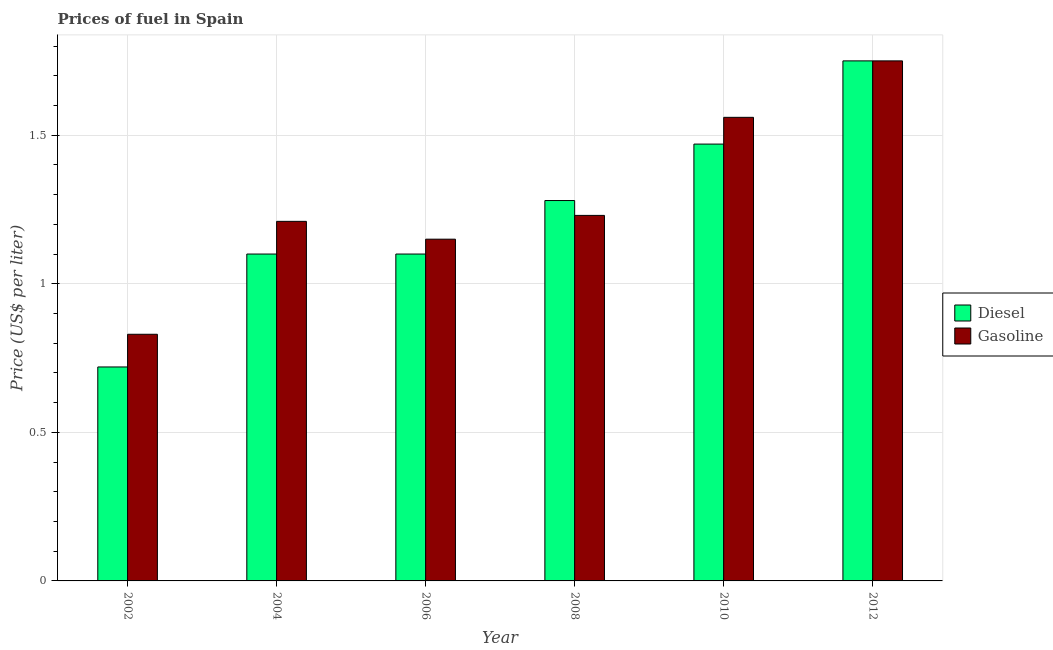Are the number of bars on each tick of the X-axis equal?
Your response must be concise. Yes. How many bars are there on the 2nd tick from the right?
Offer a terse response. 2. In how many cases, is the number of bars for a given year not equal to the number of legend labels?
Your answer should be compact. 0. What is the gasoline price in 2010?
Keep it short and to the point. 1.56. Across all years, what is the maximum gasoline price?
Your answer should be very brief. 1.75. Across all years, what is the minimum diesel price?
Ensure brevity in your answer.  0.72. In which year was the diesel price maximum?
Your answer should be compact. 2012. What is the total diesel price in the graph?
Provide a short and direct response. 7.42. What is the average gasoline price per year?
Provide a short and direct response. 1.29. In how many years, is the diesel price greater than 1.4 US$ per litre?
Provide a succinct answer. 2. What is the ratio of the gasoline price in 2008 to that in 2010?
Provide a short and direct response. 0.79. Is the difference between the gasoline price in 2004 and 2010 greater than the difference between the diesel price in 2004 and 2010?
Your answer should be very brief. No. What is the difference between the highest and the second highest gasoline price?
Offer a very short reply. 0.19. What is the difference between the highest and the lowest diesel price?
Offer a very short reply. 1.03. What does the 1st bar from the left in 2010 represents?
Your answer should be compact. Diesel. What does the 1st bar from the right in 2004 represents?
Give a very brief answer. Gasoline. How many years are there in the graph?
Your answer should be compact. 6. Does the graph contain any zero values?
Keep it short and to the point. No. How are the legend labels stacked?
Ensure brevity in your answer.  Vertical. What is the title of the graph?
Give a very brief answer. Prices of fuel in Spain. Does "Investment in Telecom" appear as one of the legend labels in the graph?
Your answer should be very brief. No. What is the label or title of the X-axis?
Provide a succinct answer. Year. What is the label or title of the Y-axis?
Provide a succinct answer. Price (US$ per liter). What is the Price (US$ per liter) in Diesel in 2002?
Provide a short and direct response. 0.72. What is the Price (US$ per liter) in Gasoline in 2002?
Your answer should be very brief. 0.83. What is the Price (US$ per liter) of Diesel in 2004?
Give a very brief answer. 1.1. What is the Price (US$ per liter) of Gasoline in 2004?
Ensure brevity in your answer.  1.21. What is the Price (US$ per liter) of Gasoline in 2006?
Provide a short and direct response. 1.15. What is the Price (US$ per liter) in Diesel in 2008?
Your response must be concise. 1.28. What is the Price (US$ per liter) in Gasoline in 2008?
Offer a very short reply. 1.23. What is the Price (US$ per liter) of Diesel in 2010?
Offer a terse response. 1.47. What is the Price (US$ per liter) in Gasoline in 2010?
Offer a very short reply. 1.56. Across all years, what is the maximum Price (US$ per liter) of Diesel?
Ensure brevity in your answer.  1.75. Across all years, what is the minimum Price (US$ per liter) in Diesel?
Your response must be concise. 0.72. Across all years, what is the minimum Price (US$ per liter) of Gasoline?
Provide a short and direct response. 0.83. What is the total Price (US$ per liter) of Diesel in the graph?
Your answer should be very brief. 7.42. What is the total Price (US$ per liter) in Gasoline in the graph?
Ensure brevity in your answer.  7.73. What is the difference between the Price (US$ per liter) of Diesel in 2002 and that in 2004?
Offer a terse response. -0.38. What is the difference between the Price (US$ per liter) of Gasoline in 2002 and that in 2004?
Offer a terse response. -0.38. What is the difference between the Price (US$ per liter) in Diesel in 2002 and that in 2006?
Provide a succinct answer. -0.38. What is the difference between the Price (US$ per liter) in Gasoline in 2002 and that in 2006?
Offer a very short reply. -0.32. What is the difference between the Price (US$ per liter) of Diesel in 2002 and that in 2008?
Your response must be concise. -0.56. What is the difference between the Price (US$ per liter) in Gasoline in 2002 and that in 2008?
Your answer should be compact. -0.4. What is the difference between the Price (US$ per liter) in Diesel in 2002 and that in 2010?
Provide a short and direct response. -0.75. What is the difference between the Price (US$ per liter) in Gasoline in 2002 and that in 2010?
Your answer should be compact. -0.73. What is the difference between the Price (US$ per liter) in Diesel in 2002 and that in 2012?
Your response must be concise. -1.03. What is the difference between the Price (US$ per liter) in Gasoline in 2002 and that in 2012?
Give a very brief answer. -0.92. What is the difference between the Price (US$ per liter) in Diesel in 2004 and that in 2006?
Ensure brevity in your answer.  0. What is the difference between the Price (US$ per liter) of Gasoline in 2004 and that in 2006?
Ensure brevity in your answer.  0.06. What is the difference between the Price (US$ per liter) in Diesel in 2004 and that in 2008?
Ensure brevity in your answer.  -0.18. What is the difference between the Price (US$ per liter) in Gasoline in 2004 and that in 2008?
Keep it short and to the point. -0.02. What is the difference between the Price (US$ per liter) of Diesel in 2004 and that in 2010?
Keep it short and to the point. -0.37. What is the difference between the Price (US$ per liter) in Gasoline in 2004 and that in 2010?
Your answer should be very brief. -0.35. What is the difference between the Price (US$ per liter) of Diesel in 2004 and that in 2012?
Make the answer very short. -0.65. What is the difference between the Price (US$ per liter) in Gasoline in 2004 and that in 2012?
Your response must be concise. -0.54. What is the difference between the Price (US$ per liter) of Diesel in 2006 and that in 2008?
Offer a very short reply. -0.18. What is the difference between the Price (US$ per liter) in Gasoline in 2006 and that in 2008?
Offer a terse response. -0.08. What is the difference between the Price (US$ per liter) of Diesel in 2006 and that in 2010?
Give a very brief answer. -0.37. What is the difference between the Price (US$ per liter) in Gasoline in 2006 and that in 2010?
Make the answer very short. -0.41. What is the difference between the Price (US$ per liter) in Diesel in 2006 and that in 2012?
Your answer should be very brief. -0.65. What is the difference between the Price (US$ per liter) of Gasoline in 2006 and that in 2012?
Keep it short and to the point. -0.6. What is the difference between the Price (US$ per liter) in Diesel in 2008 and that in 2010?
Provide a short and direct response. -0.19. What is the difference between the Price (US$ per liter) of Gasoline in 2008 and that in 2010?
Provide a short and direct response. -0.33. What is the difference between the Price (US$ per liter) in Diesel in 2008 and that in 2012?
Your response must be concise. -0.47. What is the difference between the Price (US$ per liter) of Gasoline in 2008 and that in 2012?
Give a very brief answer. -0.52. What is the difference between the Price (US$ per liter) of Diesel in 2010 and that in 2012?
Offer a terse response. -0.28. What is the difference between the Price (US$ per liter) of Gasoline in 2010 and that in 2012?
Make the answer very short. -0.19. What is the difference between the Price (US$ per liter) of Diesel in 2002 and the Price (US$ per liter) of Gasoline in 2004?
Your answer should be compact. -0.49. What is the difference between the Price (US$ per liter) in Diesel in 2002 and the Price (US$ per liter) in Gasoline in 2006?
Your answer should be compact. -0.43. What is the difference between the Price (US$ per liter) in Diesel in 2002 and the Price (US$ per liter) in Gasoline in 2008?
Ensure brevity in your answer.  -0.51. What is the difference between the Price (US$ per liter) in Diesel in 2002 and the Price (US$ per liter) in Gasoline in 2010?
Your answer should be very brief. -0.84. What is the difference between the Price (US$ per liter) of Diesel in 2002 and the Price (US$ per liter) of Gasoline in 2012?
Offer a very short reply. -1.03. What is the difference between the Price (US$ per liter) of Diesel in 2004 and the Price (US$ per liter) of Gasoline in 2008?
Your answer should be compact. -0.13. What is the difference between the Price (US$ per liter) of Diesel in 2004 and the Price (US$ per liter) of Gasoline in 2010?
Provide a short and direct response. -0.46. What is the difference between the Price (US$ per liter) in Diesel in 2004 and the Price (US$ per liter) in Gasoline in 2012?
Offer a terse response. -0.65. What is the difference between the Price (US$ per liter) in Diesel in 2006 and the Price (US$ per liter) in Gasoline in 2008?
Your response must be concise. -0.13. What is the difference between the Price (US$ per liter) of Diesel in 2006 and the Price (US$ per liter) of Gasoline in 2010?
Provide a succinct answer. -0.46. What is the difference between the Price (US$ per liter) of Diesel in 2006 and the Price (US$ per liter) of Gasoline in 2012?
Give a very brief answer. -0.65. What is the difference between the Price (US$ per liter) in Diesel in 2008 and the Price (US$ per liter) in Gasoline in 2010?
Provide a succinct answer. -0.28. What is the difference between the Price (US$ per liter) of Diesel in 2008 and the Price (US$ per liter) of Gasoline in 2012?
Provide a short and direct response. -0.47. What is the difference between the Price (US$ per liter) of Diesel in 2010 and the Price (US$ per liter) of Gasoline in 2012?
Keep it short and to the point. -0.28. What is the average Price (US$ per liter) in Diesel per year?
Give a very brief answer. 1.24. What is the average Price (US$ per liter) in Gasoline per year?
Offer a very short reply. 1.29. In the year 2002, what is the difference between the Price (US$ per liter) of Diesel and Price (US$ per liter) of Gasoline?
Make the answer very short. -0.11. In the year 2004, what is the difference between the Price (US$ per liter) in Diesel and Price (US$ per liter) in Gasoline?
Provide a short and direct response. -0.11. In the year 2006, what is the difference between the Price (US$ per liter) in Diesel and Price (US$ per liter) in Gasoline?
Your response must be concise. -0.05. In the year 2010, what is the difference between the Price (US$ per liter) in Diesel and Price (US$ per liter) in Gasoline?
Give a very brief answer. -0.09. What is the ratio of the Price (US$ per liter) in Diesel in 2002 to that in 2004?
Provide a succinct answer. 0.65. What is the ratio of the Price (US$ per liter) in Gasoline in 2002 to that in 2004?
Provide a short and direct response. 0.69. What is the ratio of the Price (US$ per liter) of Diesel in 2002 to that in 2006?
Your response must be concise. 0.65. What is the ratio of the Price (US$ per liter) of Gasoline in 2002 to that in 2006?
Ensure brevity in your answer.  0.72. What is the ratio of the Price (US$ per liter) in Diesel in 2002 to that in 2008?
Offer a terse response. 0.56. What is the ratio of the Price (US$ per liter) of Gasoline in 2002 to that in 2008?
Your answer should be very brief. 0.67. What is the ratio of the Price (US$ per liter) in Diesel in 2002 to that in 2010?
Your response must be concise. 0.49. What is the ratio of the Price (US$ per liter) of Gasoline in 2002 to that in 2010?
Your response must be concise. 0.53. What is the ratio of the Price (US$ per liter) of Diesel in 2002 to that in 2012?
Offer a terse response. 0.41. What is the ratio of the Price (US$ per liter) in Gasoline in 2002 to that in 2012?
Offer a very short reply. 0.47. What is the ratio of the Price (US$ per liter) of Gasoline in 2004 to that in 2006?
Offer a very short reply. 1.05. What is the ratio of the Price (US$ per liter) of Diesel in 2004 to that in 2008?
Give a very brief answer. 0.86. What is the ratio of the Price (US$ per liter) of Gasoline in 2004 to that in 2008?
Give a very brief answer. 0.98. What is the ratio of the Price (US$ per liter) of Diesel in 2004 to that in 2010?
Your answer should be compact. 0.75. What is the ratio of the Price (US$ per liter) in Gasoline in 2004 to that in 2010?
Your answer should be compact. 0.78. What is the ratio of the Price (US$ per liter) in Diesel in 2004 to that in 2012?
Offer a very short reply. 0.63. What is the ratio of the Price (US$ per liter) of Gasoline in 2004 to that in 2012?
Make the answer very short. 0.69. What is the ratio of the Price (US$ per liter) of Diesel in 2006 to that in 2008?
Your response must be concise. 0.86. What is the ratio of the Price (US$ per liter) in Gasoline in 2006 to that in 2008?
Offer a terse response. 0.94. What is the ratio of the Price (US$ per liter) in Diesel in 2006 to that in 2010?
Provide a short and direct response. 0.75. What is the ratio of the Price (US$ per liter) of Gasoline in 2006 to that in 2010?
Offer a very short reply. 0.74. What is the ratio of the Price (US$ per liter) of Diesel in 2006 to that in 2012?
Give a very brief answer. 0.63. What is the ratio of the Price (US$ per liter) of Gasoline in 2006 to that in 2012?
Provide a succinct answer. 0.66. What is the ratio of the Price (US$ per liter) in Diesel in 2008 to that in 2010?
Provide a short and direct response. 0.87. What is the ratio of the Price (US$ per liter) of Gasoline in 2008 to that in 2010?
Your answer should be compact. 0.79. What is the ratio of the Price (US$ per liter) in Diesel in 2008 to that in 2012?
Your response must be concise. 0.73. What is the ratio of the Price (US$ per liter) of Gasoline in 2008 to that in 2012?
Provide a short and direct response. 0.7. What is the ratio of the Price (US$ per liter) in Diesel in 2010 to that in 2012?
Give a very brief answer. 0.84. What is the ratio of the Price (US$ per liter) of Gasoline in 2010 to that in 2012?
Provide a short and direct response. 0.89. What is the difference between the highest and the second highest Price (US$ per liter) in Diesel?
Keep it short and to the point. 0.28. What is the difference between the highest and the second highest Price (US$ per liter) in Gasoline?
Your answer should be compact. 0.19. What is the difference between the highest and the lowest Price (US$ per liter) of Diesel?
Provide a short and direct response. 1.03. 